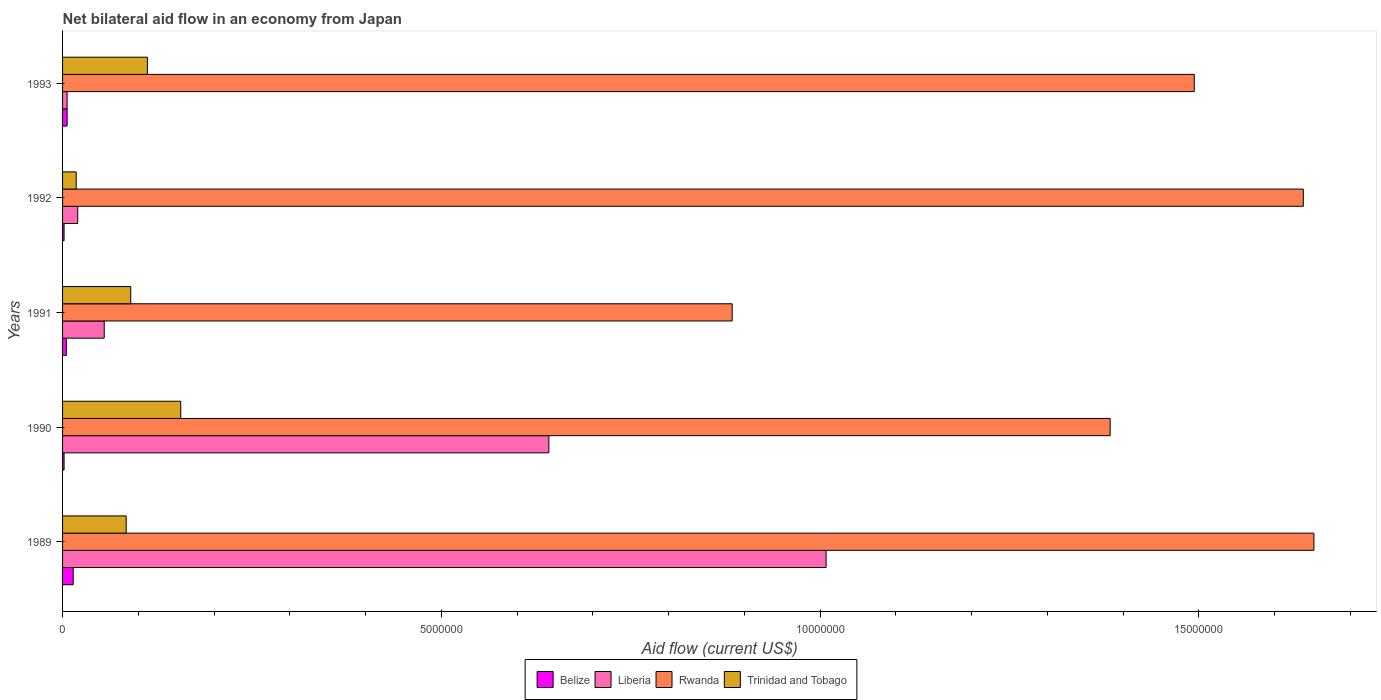Across all years, what is the maximum net bilateral aid flow in Liberia?
Your response must be concise. 1.01e+07. Across all years, what is the minimum net bilateral aid flow in Trinidad and Tobago?
Make the answer very short. 1.80e+05. In which year was the net bilateral aid flow in Liberia maximum?
Provide a succinct answer. 1989. What is the total net bilateral aid flow in Belize in the graph?
Offer a terse response. 2.90e+05. What is the difference between the net bilateral aid flow in Liberia in 1990 and that in 1991?
Offer a very short reply. 5.87e+06. What is the difference between the net bilateral aid flow in Trinidad and Tobago in 1992 and the net bilateral aid flow in Rwanda in 1991?
Provide a short and direct response. -8.66e+06. What is the average net bilateral aid flow in Trinidad and Tobago per year?
Your answer should be very brief. 9.20e+05. In the year 1989, what is the difference between the net bilateral aid flow in Liberia and net bilateral aid flow in Trinidad and Tobago?
Make the answer very short. 9.24e+06. What is the ratio of the net bilateral aid flow in Rwanda in 1991 to that in 1993?
Offer a very short reply. 0.59. Is the net bilateral aid flow in Liberia in 1989 less than that in 1993?
Offer a terse response. No. What is the difference between the highest and the lowest net bilateral aid flow in Belize?
Make the answer very short. 1.20e+05. What does the 2nd bar from the top in 1991 represents?
Keep it short and to the point. Rwanda. What does the 2nd bar from the bottom in 1990 represents?
Your answer should be compact. Liberia. Is it the case that in every year, the sum of the net bilateral aid flow in Belize and net bilateral aid flow in Trinidad and Tobago is greater than the net bilateral aid flow in Rwanda?
Provide a short and direct response. No. Are all the bars in the graph horizontal?
Your answer should be compact. Yes. Does the graph contain any zero values?
Your answer should be very brief. No. Does the graph contain grids?
Offer a terse response. No. How many legend labels are there?
Give a very brief answer. 4. What is the title of the graph?
Your answer should be compact. Net bilateral aid flow in an economy from Japan. What is the label or title of the X-axis?
Ensure brevity in your answer.  Aid flow (current US$). What is the label or title of the Y-axis?
Ensure brevity in your answer.  Years. What is the Aid flow (current US$) in Belize in 1989?
Give a very brief answer. 1.40e+05. What is the Aid flow (current US$) in Liberia in 1989?
Keep it short and to the point. 1.01e+07. What is the Aid flow (current US$) in Rwanda in 1989?
Provide a succinct answer. 1.65e+07. What is the Aid flow (current US$) in Trinidad and Tobago in 1989?
Make the answer very short. 8.40e+05. What is the Aid flow (current US$) in Belize in 1990?
Make the answer very short. 2.00e+04. What is the Aid flow (current US$) in Liberia in 1990?
Give a very brief answer. 6.42e+06. What is the Aid flow (current US$) of Rwanda in 1990?
Provide a short and direct response. 1.38e+07. What is the Aid flow (current US$) of Trinidad and Tobago in 1990?
Give a very brief answer. 1.56e+06. What is the Aid flow (current US$) in Belize in 1991?
Ensure brevity in your answer.  5.00e+04. What is the Aid flow (current US$) of Liberia in 1991?
Your answer should be very brief. 5.50e+05. What is the Aid flow (current US$) of Rwanda in 1991?
Ensure brevity in your answer.  8.84e+06. What is the Aid flow (current US$) in Trinidad and Tobago in 1991?
Your answer should be compact. 9.00e+05. What is the Aid flow (current US$) of Belize in 1992?
Your answer should be very brief. 2.00e+04. What is the Aid flow (current US$) in Liberia in 1992?
Give a very brief answer. 2.00e+05. What is the Aid flow (current US$) of Rwanda in 1992?
Provide a short and direct response. 1.64e+07. What is the Aid flow (current US$) of Belize in 1993?
Make the answer very short. 6.00e+04. What is the Aid flow (current US$) in Rwanda in 1993?
Your answer should be very brief. 1.49e+07. What is the Aid flow (current US$) of Trinidad and Tobago in 1993?
Offer a very short reply. 1.12e+06. Across all years, what is the maximum Aid flow (current US$) of Liberia?
Your answer should be compact. 1.01e+07. Across all years, what is the maximum Aid flow (current US$) of Rwanda?
Your answer should be very brief. 1.65e+07. Across all years, what is the maximum Aid flow (current US$) of Trinidad and Tobago?
Your answer should be very brief. 1.56e+06. Across all years, what is the minimum Aid flow (current US$) of Belize?
Provide a short and direct response. 2.00e+04. Across all years, what is the minimum Aid flow (current US$) of Rwanda?
Offer a very short reply. 8.84e+06. Across all years, what is the minimum Aid flow (current US$) of Trinidad and Tobago?
Provide a succinct answer. 1.80e+05. What is the total Aid flow (current US$) of Liberia in the graph?
Keep it short and to the point. 1.73e+07. What is the total Aid flow (current US$) in Rwanda in the graph?
Your answer should be very brief. 7.05e+07. What is the total Aid flow (current US$) of Trinidad and Tobago in the graph?
Offer a very short reply. 4.60e+06. What is the difference between the Aid flow (current US$) in Belize in 1989 and that in 1990?
Make the answer very short. 1.20e+05. What is the difference between the Aid flow (current US$) of Liberia in 1989 and that in 1990?
Make the answer very short. 3.66e+06. What is the difference between the Aid flow (current US$) of Rwanda in 1989 and that in 1990?
Make the answer very short. 2.69e+06. What is the difference between the Aid flow (current US$) in Trinidad and Tobago in 1989 and that in 1990?
Your response must be concise. -7.20e+05. What is the difference between the Aid flow (current US$) in Liberia in 1989 and that in 1991?
Give a very brief answer. 9.53e+06. What is the difference between the Aid flow (current US$) in Rwanda in 1989 and that in 1991?
Make the answer very short. 7.68e+06. What is the difference between the Aid flow (current US$) in Liberia in 1989 and that in 1992?
Your response must be concise. 9.88e+06. What is the difference between the Aid flow (current US$) in Trinidad and Tobago in 1989 and that in 1992?
Make the answer very short. 6.60e+05. What is the difference between the Aid flow (current US$) in Liberia in 1989 and that in 1993?
Provide a succinct answer. 1.00e+07. What is the difference between the Aid flow (current US$) in Rwanda in 1989 and that in 1993?
Your answer should be compact. 1.58e+06. What is the difference between the Aid flow (current US$) of Trinidad and Tobago in 1989 and that in 1993?
Your answer should be compact. -2.80e+05. What is the difference between the Aid flow (current US$) of Liberia in 1990 and that in 1991?
Provide a short and direct response. 5.87e+06. What is the difference between the Aid flow (current US$) of Rwanda in 1990 and that in 1991?
Your answer should be very brief. 4.99e+06. What is the difference between the Aid flow (current US$) of Liberia in 1990 and that in 1992?
Provide a short and direct response. 6.22e+06. What is the difference between the Aid flow (current US$) of Rwanda in 1990 and that in 1992?
Your answer should be very brief. -2.55e+06. What is the difference between the Aid flow (current US$) of Trinidad and Tobago in 1990 and that in 1992?
Keep it short and to the point. 1.38e+06. What is the difference between the Aid flow (current US$) of Liberia in 1990 and that in 1993?
Offer a terse response. 6.36e+06. What is the difference between the Aid flow (current US$) of Rwanda in 1990 and that in 1993?
Make the answer very short. -1.11e+06. What is the difference between the Aid flow (current US$) in Trinidad and Tobago in 1990 and that in 1993?
Offer a terse response. 4.40e+05. What is the difference between the Aid flow (current US$) of Rwanda in 1991 and that in 1992?
Your response must be concise. -7.54e+06. What is the difference between the Aid flow (current US$) in Trinidad and Tobago in 1991 and that in 1992?
Provide a succinct answer. 7.20e+05. What is the difference between the Aid flow (current US$) of Belize in 1991 and that in 1993?
Keep it short and to the point. -10000. What is the difference between the Aid flow (current US$) of Rwanda in 1991 and that in 1993?
Your response must be concise. -6.10e+06. What is the difference between the Aid flow (current US$) of Rwanda in 1992 and that in 1993?
Your response must be concise. 1.44e+06. What is the difference between the Aid flow (current US$) in Trinidad and Tobago in 1992 and that in 1993?
Make the answer very short. -9.40e+05. What is the difference between the Aid flow (current US$) of Belize in 1989 and the Aid flow (current US$) of Liberia in 1990?
Make the answer very short. -6.28e+06. What is the difference between the Aid flow (current US$) of Belize in 1989 and the Aid flow (current US$) of Rwanda in 1990?
Your response must be concise. -1.37e+07. What is the difference between the Aid flow (current US$) of Belize in 1989 and the Aid flow (current US$) of Trinidad and Tobago in 1990?
Offer a terse response. -1.42e+06. What is the difference between the Aid flow (current US$) in Liberia in 1989 and the Aid flow (current US$) in Rwanda in 1990?
Provide a succinct answer. -3.75e+06. What is the difference between the Aid flow (current US$) in Liberia in 1989 and the Aid flow (current US$) in Trinidad and Tobago in 1990?
Your response must be concise. 8.52e+06. What is the difference between the Aid flow (current US$) in Rwanda in 1989 and the Aid flow (current US$) in Trinidad and Tobago in 1990?
Provide a succinct answer. 1.50e+07. What is the difference between the Aid flow (current US$) of Belize in 1989 and the Aid flow (current US$) of Liberia in 1991?
Offer a very short reply. -4.10e+05. What is the difference between the Aid flow (current US$) of Belize in 1989 and the Aid flow (current US$) of Rwanda in 1991?
Offer a very short reply. -8.70e+06. What is the difference between the Aid flow (current US$) in Belize in 1989 and the Aid flow (current US$) in Trinidad and Tobago in 1991?
Provide a short and direct response. -7.60e+05. What is the difference between the Aid flow (current US$) in Liberia in 1989 and the Aid flow (current US$) in Rwanda in 1991?
Offer a terse response. 1.24e+06. What is the difference between the Aid flow (current US$) in Liberia in 1989 and the Aid flow (current US$) in Trinidad and Tobago in 1991?
Your response must be concise. 9.18e+06. What is the difference between the Aid flow (current US$) of Rwanda in 1989 and the Aid flow (current US$) of Trinidad and Tobago in 1991?
Keep it short and to the point. 1.56e+07. What is the difference between the Aid flow (current US$) in Belize in 1989 and the Aid flow (current US$) in Rwanda in 1992?
Your answer should be very brief. -1.62e+07. What is the difference between the Aid flow (current US$) in Belize in 1989 and the Aid flow (current US$) in Trinidad and Tobago in 1992?
Your response must be concise. -4.00e+04. What is the difference between the Aid flow (current US$) of Liberia in 1989 and the Aid flow (current US$) of Rwanda in 1992?
Offer a terse response. -6.30e+06. What is the difference between the Aid flow (current US$) of Liberia in 1989 and the Aid flow (current US$) of Trinidad and Tobago in 1992?
Your answer should be compact. 9.90e+06. What is the difference between the Aid flow (current US$) in Rwanda in 1989 and the Aid flow (current US$) in Trinidad and Tobago in 1992?
Your response must be concise. 1.63e+07. What is the difference between the Aid flow (current US$) in Belize in 1989 and the Aid flow (current US$) in Rwanda in 1993?
Your response must be concise. -1.48e+07. What is the difference between the Aid flow (current US$) of Belize in 1989 and the Aid flow (current US$) of Trinidad and Tobago in 1993?
Offer a terse response. -9.80e+05. What is the difference between the Aid flow (current US$) in Liberia in 1989 and the Aid flow (current US$) in Rwanda in 1993?
Keep it short and to the point. -4.86e+06. What is the difference between the Aid flow (current US$) in Liberia in 1989 and the Aid flow (current US$) in Trinidad and Tobago in 1993?
Provide a succinct answer. 8.96e+06. What is the difference between the Aid flow (current US$) in Rwanda in 1989 and the Aid flow (current US$) in Trinidad and Tobago in 1993?
Your answer should be compact. 1.54e+07. What is the difference between the Aid flow (current US$) in Belize in 1990 and the Aid flow (current US$) in Liberia in 1991?
Make the answer very short. -5.30e+05. What is the difference between the Aid flow (current US$) in Belize in 1990 and the Aid flow (current US$) in Rwanda in 1991?
Ensure brevity in your answer.  -8.82e+06. What is the difference between the Aid flow (current US$) of Belize in 1990 and the Aid flow (current US$) of Trinidad and Tobago in 1991?
Make the answer very short. -8.80e+05. What is the difference between the Aid flow (current US$) of Liberia in 1990 and the Aid flow (current US$) of Rwanda in 1991?
Offer a terse response. -2.42e+06. What is the difference between the Aid flow (current US$) in Liberia in 1990 and the Aid flow (current US$) in Trinidad and Tobago in 1991?
Provide a succinct answer. 5.52e+06. What is the difference between the Aid flow (current US$) in Rwanda in 1990 and the Aid flow (current US$) in Trinidad and Tobago in 1991?
Ensure brevity in your answer.  1.29e+07. What is the difference between the Aid flow (current US$) in Belize in 1990 and the Aid flow (current US$) in Liberia in 1992?
Your answer should be compact. -1.80e+05. What is the difference between the Aid flow (current US$) in Belize in 1990 and the Aid flow (current US$) in Rwanda in 1992?
Your answer should be very brief. -1.64e+07. What is the difference between the Aid flow (current US$) in Liberia in 1990 and the Aid flow (current US$) in Rwanda in 1992?
Your answer should be compact. -9.96e+06. What is the difference between the Aid flow (current US$) in Liberia in 1990 and the Aid flow (current US$) in Trinidad and Tobago in 1992?
Keep it short and to the point. 6.24e+06. What is the difference between the Aid flow (current US$) of Rwanda in 1990 and the Aid flow (current US$) of Trinidad and Tobago in 1992?
Provide a short and direct response. 1.36e+07. What is the difference between the Aid flow (current US$) of Belize in 1990 and the Aid flow (current US$) of Rwanda in 1993?
Make the answer very short. -1.49e+07. What is the difference between the Aid flow (current US$) in Belize in 1990 and the Aid flow (current US$) in Trinidad and Tobago in 1993?
Your response must be concise. -1.10e+06. What is the difference between the Aid flow (current US$) in Liberia in 1990 and the Aid flow (current US$) in Rwanda in 1993?
Make the answer very short. -8.52e+06. What is the difference between the Aid flow (current US$) in Liberia in 1990 and the Aid flow (current US$) in Trinidad and Tobago in 1993?
Provide a short and direct response. 5.30e+06. What is the difference between the Aid flow (current US$) in Rwanda in 1990 and the Aid flow (current US$) in Trinidad and Tobago in 1993?
Your answer should be compact. 1.27e+07. What is the difference between the Aid flow (current US$) in Belize in 1991 and the Aid flow (current US$) in Liberia in 1992?
Your response must be concise. -1.50e+05. What is the difference between the Aid flow (current US$) in Belize in 1991 and the Aid flow (current US$) in Rwanda in 1992?
Offer a terse response. -1.63e+07. What is the difference between the Aid flow (current US$) of Liberia in 1991 and the Aid flow (current US$) of Rwanda in 1992?
Your answer should be compact. -1.58e+07. What is the difference between the Aid flow (current US$) in Liberia in 1991 and the Aid flow (current US$) in Trinidad and Tobago in 1992?
Provide a short and direct response. 3.70e+05. What is the difference between the Aid flow (current US$) in Rwanda in 1991 and the Aid flow (current US$) in Trinidad and Tobago in 1992?
Offer a terse response. 8.66e+06. What is the difference between the Aid flow (current US$) in Belize in 1991 and the Aid flow (current US$) in Rwanda in 1993?
Offer a terse response. -1.49e+07. What is the difference between the Aid flow (current US$) of Belize in 1991 and the Aid flow (current US$) of Trinidad and Tobago in 1993?
Offer a very short reply. -1.07e+06. What is the difference between the Aid flow (current US$) in Liberia in 1991 and the Aid flow (current US$) in Rwanda in 1993?
Provide a short and direct response. -1.44e+07. What is the difference between the Aid flow (current US$) in Liberia in 1991 and the Aid flow (current US$) in Trinidad and Tobago in 1993?
Keep it short and to the point. -5.70e+05. What is the difference between the Aid flow (current US$) in Rwanda in 1991 and the Aid flow (current US$) in Trinidad and Tobago in 1993?
Your answer should be compact. 7.72e+06. What is the difference between the Aid flow (current US$) in Belize in 1992 and the Aid flow (current US$) in Rwanda in 1993?
Keep it short and to the point. -1.49e+07. What is the difference between the Aid flow (current US$) of Belize in 1992 and the Aid flow (current US$) of Trinidad and Tobago in 1993?
Offer a very short reply. -1.10e+06. What is the difference between the Aid flow (current US$) of Liberia in 1992 and the Aid flow (current US$) of Rwanda in 1993?
Provide a short and direct response. -1.47e+07. What is the difference between the Aid flow (current US$) in Liberia in 1992 and the Aid flow (current US$) in Trinidad and Tobago in 1993?
Give a very brief answer. -9.20e+05. What is the difference between the Aid flow (current US$) in Rwanda in 1992 and the Aid flow (current US$) in Trinidad and Tobago in 1993?
Offer a terse response. 1.53e+07. What is the average Aid flow (current US$) of Belize per year?
Offer a terse response. 5.80e+04. What is the average Aid flow (current US$) in Liberia per year?
Offer a terse response. 3.46e+06. What is the average Aid flow (current US$) of Rwanda per year?
Offer a very short reply. 1.41e+07. What is the average Aid flow (current US$) in Trinidad and Tobago per year?
Provide a succinct answer. 9.20e+05. In the year 1989, what is the difference between the Aid flow (current US$) of Belize and Aid flow (current US$) of Liberia?
Your answer should be compact. -9.94e+06. In the year 1989, what is the difference between the Aid flow (current US$) in Belize and Aid flow (current US$) in Rwanda?
Your answer should be very brief. -1.64e+07. In the year 1989, what is the difference between the Aid flow (current US$) of Belize and Aid flow (current US$) of Trinidad and Tobago?
Make the answer very short. -7.00e+05. In the year 1989, what is the difference between the Aid flow (current US$) of Liberia and Aid flow (current US$) of Rwanda?
Your answer should be very brief. -6.44e+06. In the year 1989, what is the difference between the Aid flow (current US$) of Liberia and Aid flow (current US$) of Trinidad and Tobago?
Offer a very short reply. 9.24e+06. In the year 1989, what is the difference between the Aid flow (current US$) of Rwanda and Aid flow (current US$) of Trinidad and Tobago?
Ensure brevity in your answer.  1.57e+07. In the year 1990, what is the difference between the Aid flow (current US$) in Belize and Aid flow (current US$) in Liberia?
Provide a short and direct response. -6.40e+06. In the year 1990, what is the difference between the Aid flow (current US$) of Belize and Aid flow (current US$) of Rwanda?
Provide a short and direct response. -1.38e+07. In the year 1990, what is the difference between the Aid flow (current US$) of Belize and Aid flow (current US$) of Trinidad and Tobago?
Provide a succinct answer. -1.54e+06. In the year 1990, what is the difference between the Aid flow (current US$) of Liberia and Aid flow (current US$) of Rwanda?
Offer a very short reply. -7.41e+06. In the year 1990, what is the difference between the Aid flow (current US$) in Liberia and Aid flow (current US$) in Trinidad and Tobago?
Make the answer very short. 4.86e+06. In the year 1990, what is the difference between the Aid flow (current US$) in Rwanda and Aid flow (current US$) in Trinidad and Tobago?
Make the answer very short. 1.23e+07. In the year 1991, what is the difference between the Aid flow (current US$) of Belize and Aid flow (current US$) of Liberia?
Give a very brief answer. -5.00e+05. In the year 1991, what is the difference between the Aid flow (current US$) of Belize and Aid flow (current US$) of Rwanda?
Make the answer very short. -8.79e+06. In the year 1991, what is the difference between the Aid flow (current US$) of Belize and Aid flow (current US$) of Trinidad and Tobago?
Your answer should be compact. -8.50e+05. In the year 1991, what is the difference between the Aid flow (current US$) of Liberia and Aid flow (current US$) of Rwanda?
Provide a succinct answer. -8.29e+06. In the year 1991, what is the difference between the Aid flow (current US$) of Liberia and Aid flow (current US$) of Trinidad and Tobago?
Your response must be concise. -3.50e+05. In the year 1991, what is the difference between the Aid flow (current US$) in Rwanda and Aid flow (current US$) in Trinidad and Tobago?
Your answer should be compact. 7.94e+06. In the year 1992, what is the difference between the Aid flow (current US$) of Belize and Aid flow (current US$) of Liberia?
Ensure brevity in your answer.  -1.80e+05. In the year 1992, what is the difference between the Aid flow (current US$) of Belize and Aid flow (current US$) of Rwanda?
Your response must be concise. -1.64e+07. In the year 1992, what is the difference between the Aid flow (current US$) in Belize and Aid flow (current US$) in Trinidad and Tobago?
Your answer should be very brief. -1.60e+05. In the year 1992, what is the difference between the Aid flow (current US$) in Liberia and Aid flow (current US$) in Rwanda?
Offer a very short reply. -1.62e+07. In the year 1992, what is the difference between the Aid flow (current US$) in Rwanda and Aid flow (current US$) in Trinidad and Tobago?
Provide a succinct answer. 1.62e+07. In the year 1993, what is the difference between the Aid flow (current US$) in Belize and Aid flow (current US$) in Liberia?
Provide a short and direct response. 0. In the year 1993, what is the difference between the Aid flow (current US$) in Belize and Aid flow (current US$) in Rwanda?
Ensure brevity in your answer.  -1.49e+07. In the year 1993, what is the difference between the Aid flow (current US$) in Belize and Aid flow (current US$) in Trinidad and Tobago?
Your answer should be compact. -1.06e+06. In the year 1993, what is the difference between the Aid flow (current US$) of Liberia and Aid flow (current US$) of Rwanda?
Ensure brevity in your answer.  -1.49e+07. In the year 1993, what is the difference between the Aid flow (current US$) in Liberia and Aid flow (current US$) in Trinidad and Tobago?
Your response must be concise. -1.06e+06. In the year 1993, what is the difference between the Aid flow (current US$) of Rwanda and Aid flow (current US$) of Trinidad and Tobago?
Your answer should be compact. 1.38e+07. What is the ratio of the Aid flow (current US$) of Liberia in 1989 to that in 1990?
Your answer should be compact. 1.57. What is the ratio of the Aid flow (current US$) of Rwanda in 1989 to that in 1990?
Your answer should be very brief. 1.19. What is the ratio of the Aid flow (current US$) in Trinidad and Tobago in 1989 to that in 1990?
Your answer should be very brief. 0.54. What is the ratio of the Aid flow (current US$) in Liberia in 1989 to that in 1991?
Your answer should be compact. 18.33. What is the ratio of the Aid flow (current US$) of Rwanda in 1989 to that in 1991?
Give a very brief answer. 1.87. What is the ratio of the Aid flow (current US$) in Liberia in 1989 to that in 1992?
Your answer should be very brief. 50.4. What is the ratio of the Aid flow (current US$) in Rwanda in 1989 to that in 1992?
Make the answer very short. 1.01. What is the ratio of the Aid flow (current US$) in Trinidad and Tobago in 1989 to that in 1992?
Provide a succinct answer. 4.67. What is the ratio of the Aid flow (current US$) of Belize in 1989 to that in 1993?
Offer a very short reply. 2.33. What is the ratio of the Aid flow (current US$) in Liberia in 1989 to that in 1993?
Make the answer very short. 168. What is the ratio of the Aid flow (current US$) of Rwanda in 1989 to that in 1993?
Offer a very short reply. 1.11. What is the ratio of the Aid flow (current US$) of Trinidad and Tobago in 1989 to that in 1993?
Offer a very short reply. 0.75. What is the ratio of the Aid flow (current US$) in Liberia in 1990 to that in 1991?
Your response must be concise. 11.67. What is the ratio of the Aid flow (current US$) in Rwanda in 1990 to that in 1991?
Give a very brief answer. 1.56. What is the ratio of the Aid flow (current US$) in Trinidad and Tobago in 1990 to that in 1991?
Give a very brief answer. 1.73. What is the ratio of the Aid flow (current US$) in Belize in 1990 to that in 1992?
Make the answer very short. 1. What is the ratio of the Aid flow (current US$) of Liberia in 1990 to that in 1992?
Provide a short and direct response. 32.1. What is the ratio of the Aid flow (current US$) in Rwanda in 1990 to that in 1992?
Your answer should be very brief. 0.84. What is the ratio of the Aid flow (current US$) of Trinidad and Tobago in 1990 to that in 1992?
Keep it short and to the point. 8.67. What is the ratio of the Aid flow (current US$) of Liberia in 1990 to that in 1993?
Ensure brevity in your answer.  107. What is the ratio of the Aid flow (current US$) of Rwanda in 1990 to that in 1993?
Make the answer very short. 0.93. What is the ratio of the Aid flow (current US$) of Trinidad and Tobago in 1990 to that in 1993?
Your answer should be very brief. 1.39. What is the ratio of the Aid flow (current US$) in Belize in 1991 to that in 1992?
Provide a short and direct response. 2.5. What is the ratio of the Aid flow (current US$) of Liberia in 1991 to that in 1992?
Your answer should be very brief. 2.75. What is the ratio of the Aid flow (current US$) in Rwanda in 1991 to that in 1992?
Offer a very short reply. 0.54. What is the ratio of the Aid flow (current US$) in Trinidad and Tobago in 1991 to that in 1992?
Offer a very short reply. 5. What is the ratio of the Aid flow (current US$) in Belize in 1991 to that in 1993?
Give a very brief answer. 0.83. What is the ratio of the Aid flow (current US$) of Liberia in 1991 to that in 1993?
Offer a very short reply. 9.17. What is the ratio of the Aid flow (current US$) of Rwanda in 1991 to that in 1993?
Offer a terse response. 0.59. What is the ratio of the Aid flow (current US$) of Trinidad and Tobago in 1991 to that in 1993?
Provide a succinct answer. 0.8. What is the ratio of the Aid flow (current US$) in Liberia in 1992 to that in 1993?
Ensure brevity in your answer.  3.33. What is the ratio of the Aid flow (current US$) of Rwanda in 1992 to that in 1993?
Make the answer very short. 1.1. What is the ratio of the Aid flow (current US$) of Trinidad and Tobago in 1992 to that in 1993?
Provide a succinct answer. 0.16. What is the difference between the highest and the second highest Aid flow (current US$) of Belize?
Ensure brevity in your answer.  8.00e+04. What is the difference between the highest and the second highest Aid flow (current US$) of Liberia?
Your response must be concise. 3.66e+06. What is the difference between the highest and the lowest Aid flow (current US$) in Belize?
Your answer should be very brief. 1.20e+05. What is the difference between the highest and the lowest Aid flow (current US$) in Liberia?
Make the answer very short. 1.00e+07. What is the difference between the highest and the lowest Aid flow (current US$) in Rwanda?
Keep it short and to the point. 7.68e+06. What is the difference between the highest and the lowest Aid flow (current US$) in Trinidad and Tobago?
Provide a short and direct response. 1.38e+06. 